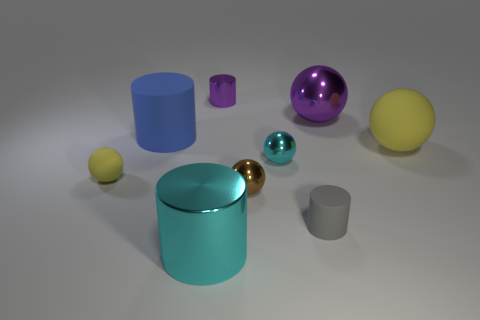Subtract 1 cylinders. How many cylinders are left? 3 Subtract all cyan spheres. How many spheres are left? 4 Subtract all purple shiny cylinders. How many cylinders are left? 3 Subtract all red cylinders. Subtract all red cubes. How many cylinders are left? 4 Subtract all spheres. How many objects are left? 4 Add 3 big blue rubber things. How many big blue rubber things are left? 4 Add 9 gray cylinders. How many gray cylinders exist? 10 Subtract 0 red cylinders. How many objects are left? 9 Subtract all yellow rubber balls. Subtract all purple objects. How many objects are left? 5 